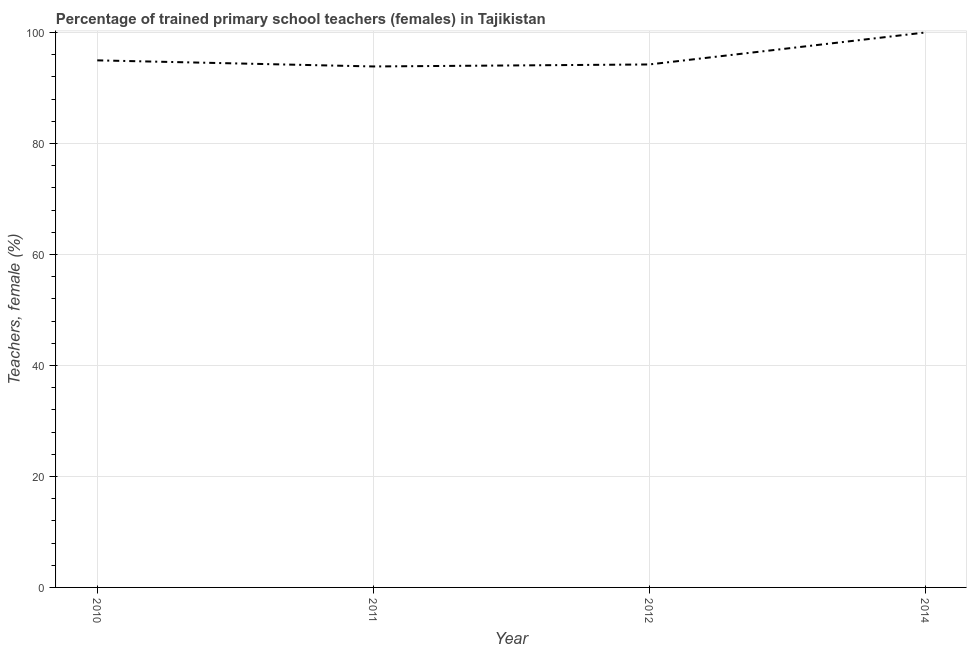What is the percentage of trained female teachers in 2011?
Provide a succinct answer. 93.88. Across all years, what is the maximum percentage of trained female teachers?
Provide a succinct answer. 100. Across all years, what is the minimum percentage of trained female teachers?
Make the answer very short. 93.88. In which year was the percentage of trained female teachers maximum?
Ensure brevity in your answer.  2014. In which year was the percentage of trained female teachers minimum?
Provide a succinct answer. 2011. What is the sum of the percentage of trained female teachers?
Offer a very short reply. 383.11. What is the difference between the percentage of trained female teachers in 2010 and 2014?
Your answer should be very brief. -5.02. What is the average percentage of trained female teachers per year?
Offer a terse response. 95.78. What is the median percentage of trained female teachers?
Your answer should be compact. 94.61. In how many years, is the percentage of trained female teachers greater than 72 %?
Keep it short and to the point. 4. Do a majority of the years between 2011 and 2014 (inclusive) have percentage of trained female teachers greater than 96 %?
Keep it short and to the point. No. What is the ratio of the percentage of trained female teachers in 2010 to that in 2012?
Make the answer very short. 1.01. Is the percentage of trained female teachers in 2011 less than that in 2012?
Your answer should be compact. Yes. Is the difference between the percentage of trained female teachers in 2012 and 2014 greater than the difference between any two years?
Make the answer very short. No. What is the difference between the highest and the second highest percentage of trained female teachers?
Provide a short and direct response. 5.02. What is the difference between the highest and the lowest percentage of trained female teachers?
Offer a terse response. 6.12. In how many years, is the percentage of trained female teachers greater than the average percentage of trained female teachers taken over all years?
Provide a succinct answer. 1. How many years are there in the graph?
Provide a succinct answer. 4. What is the difference between two consecutive major ticks on the Y-axis?
Your answer should be very brief. 20. What is the title of the graph?
Give a very brief answer. Percentage of trained primary school teachers (females) in Tajikistan. What is the label or title of the Y-axis?
Offer a terse response. Teachers, female (%). What is the Teachers, female (%) of 2010?
Offer a terse response. 94.98. What is the Teachers, female (%) of 2011?
Your response must be concise. 93.88. What is the Teachers, female (%) of 2012?
Give a very brief answer. 94.24. What is the difference between the Teachers, female (%) in 2010 and 2011?
Provide a succinct answer. 1.1. What is the difference between the Teachers, female (%) in 2010 and 2012?
Provide a succinct answer. 0.74. What is the difference between the Teachers, female (%) in 2010 and 2014?
Your answer should be compact. -5.02. What is the difference between the Teachers, female (%) in 2011 and 2012?
Your response must be concise. -0.36. What is the difference between the Teachers, female (%) in 2011 and 2014?
Provide a succinct answer. -6.12. What is the difference between the Teachers, female (%) in 2012 and 2014?
Ensure brevity in your answer.  -5.76. What is the ratio of the Teachers, female (%) in 2010 to that in 2011?
Ensure brevity in your answer.  1.01. What is the ratio of the Teachers, female (%) in 2010 to that in 2012?
Provide a short and direct response. 1.01. What is the ratio of the Teachers, female (%) in 2010 to that in 2014?
Offer a terse response. 0.95. What is the ratio of the Teachers, female (%) in 2011 to that in 2014?
Offer a terse response. 0.94. What is the ratio of the Teachers, female (%) in 2012 to that in 2014?
Offer a terse response. 0.94. 